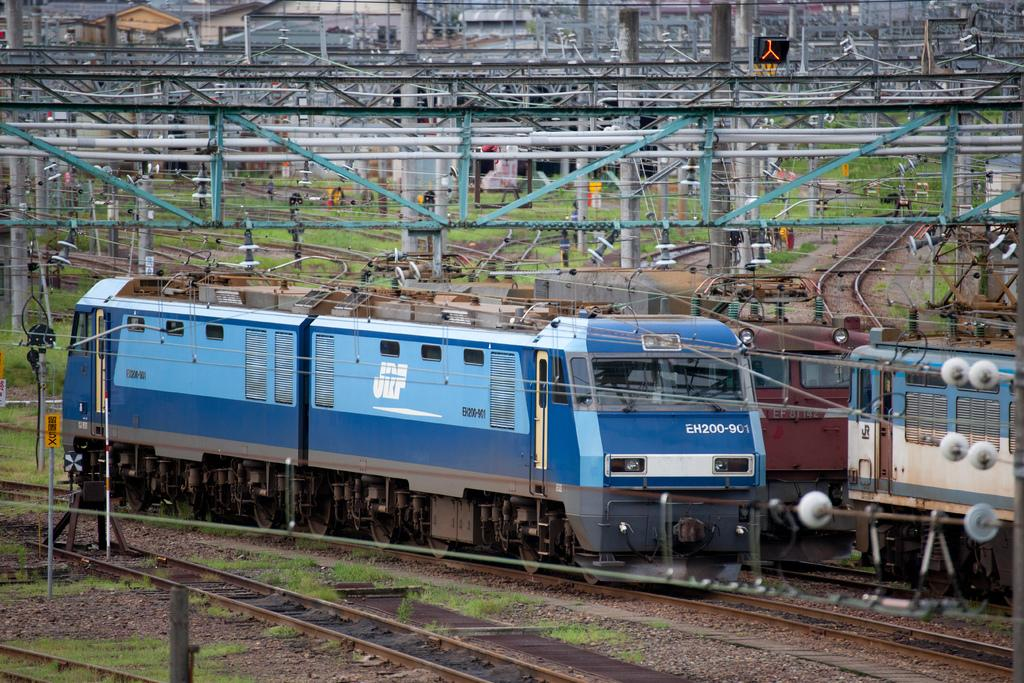<image>
Relay a brief, clear account of the picture shown. A blue train that sayss EH200-901 on the front of it. 